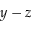Convert formula to latex. <formula><loc_0><loc_0><loc_500><loc_500>y - z</formula> 